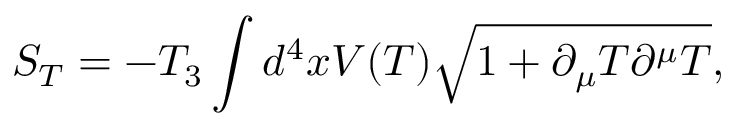<formula> <loc_0><loc_0><loc_500><loc_500>S _ { T } = - T _ { 3 } \int d ^ { 4 } x V ( T ) \sqrt { 1 + \partial _ { \mu } T \partial ^ { \mu } T } ,</formula> 